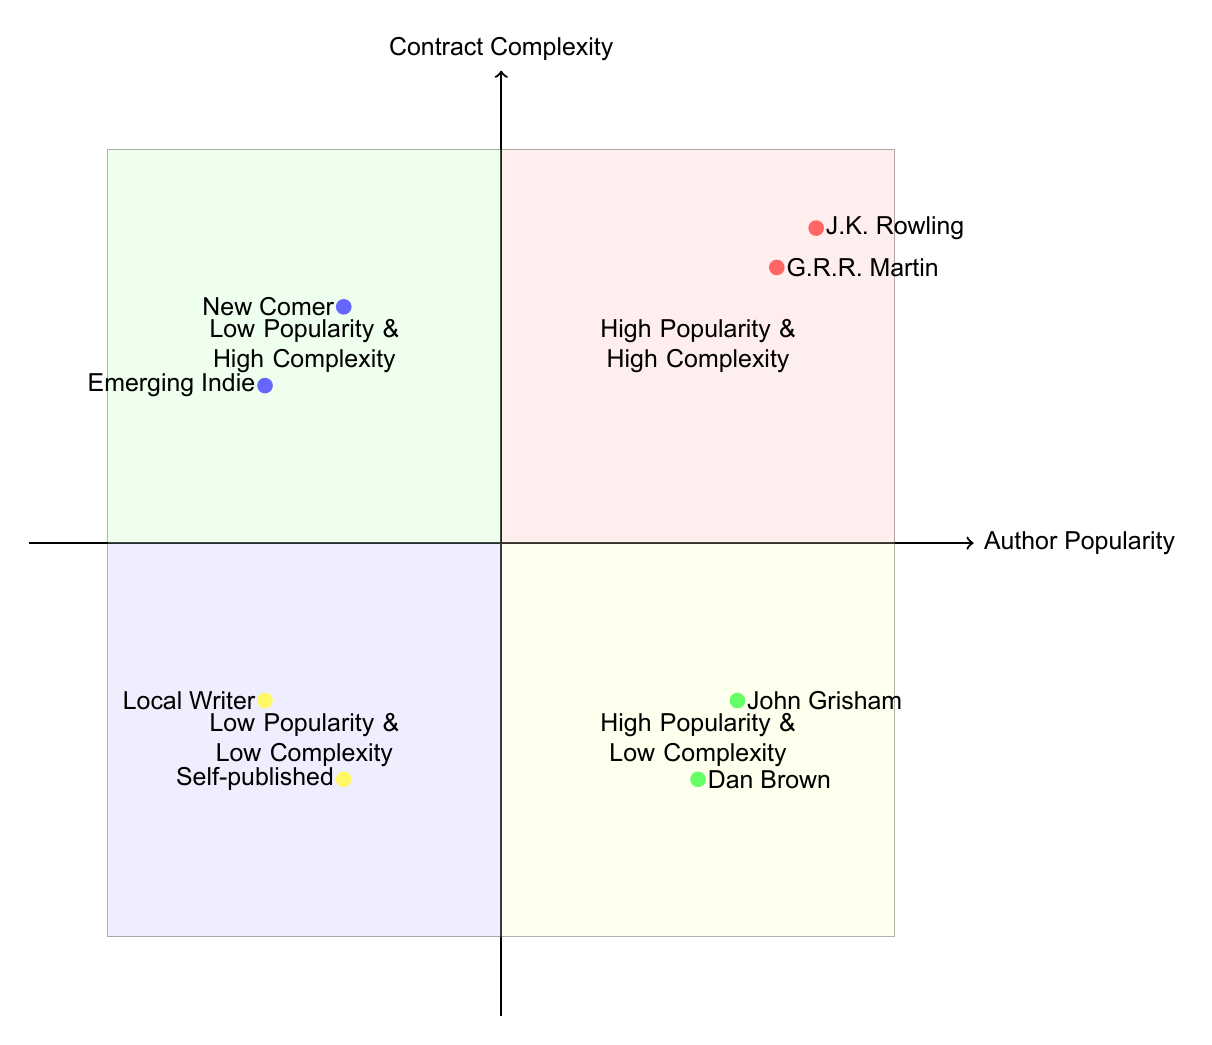What authors fall into the high popularity & high complexity quadrant? The high popularity & high complexity quadrant includes J.K. Rowling and George R.R. Martin as indicated by their positions in this section of the diagram.
Answer: J.K. Rowling, George R.R. Martin How many authors are in the low popularity & low complexity quadrant? There are two authors listed in the low popularity & low complexity quadrant: a self-published author and a local writer.
Answer: 2 Which genre is represented by John Grisham? John Grisham is positioned in the high popularity & low complexity quadrant, and his genre is identified as Legal Thriller in the diagram.
Answer: Legal Thriller What contract elements are associated with George R.R. Martin? The contract elements for George R.R. Martin include merchandising rights, franchise agreements, and multi-format releases, as shown in the description provided for the high popularity & high complexity quadrant.
Answer: Merchandising rights, franchise agreements, multi-format releases Which quadrant has the highest author popularity and how many authors are there? The quadrant with the highest author popularity is the high popularity & high complexity quadrant, and it contains two authors, as seen in the authors listed there.
Answer: 2 Which genre has authors with the lowest complexity and popularity? The genre represented by authors in the low popularity & low complexity quadrant includes Non-Fiction Self Help and Poetry, signified by the self-published author and the local writer, respectively.
Answer: Non-Fiction Self Help, Poetry Which author has a single book deal contract? In the low complexity & high popularity quadrant, John Grisham is noted for having a single book deal contract, verifying his classification in this section of the diagram.
Answer: John Grisham What is the genre of the emerging indie author? The emerging indie author is categorized under the Science Fiction genre according to their placement in the low popularity & high complexity quadrant of the diagram.
Answer: Science Fiction 